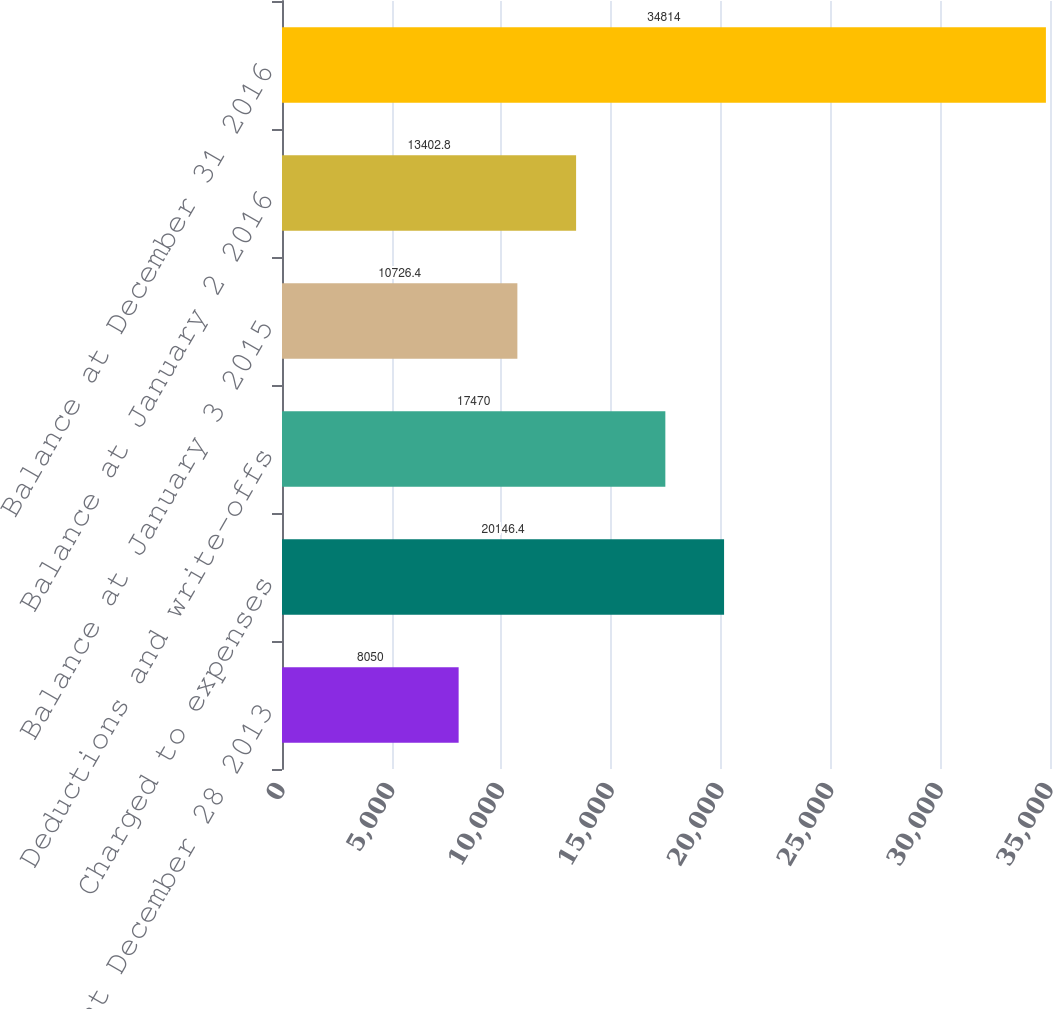<chart> <loc_0><loc_0><loc_500><loc_500><bar_chart><fcel>Balance at December 28 2013<fcel>Charged to expenses<fcel>Deductions and write-offs<fcel>Balance at January 3 2015<fcel>Balance at January 2 2016<fcel>Balance at December 31 2016<nl><fcel>8050<fcel>20146.4<fcel>17470<fcel>10726.4<fcel>13402.8<fcel>34814<nl></chart> 